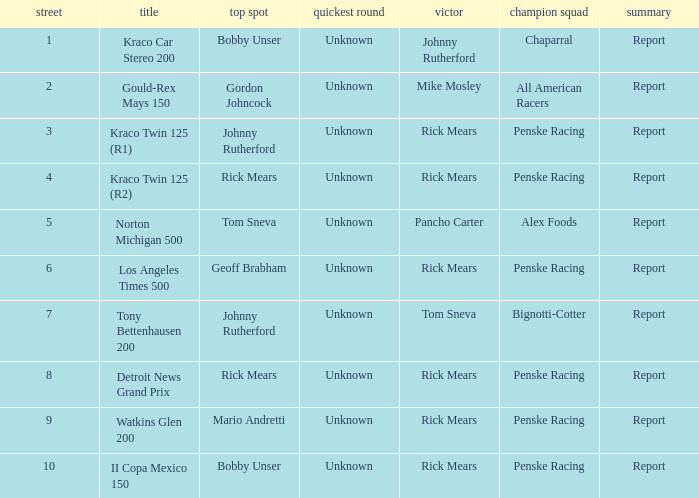How many fastest laps were there for a rd that equals 10? 1.0. 